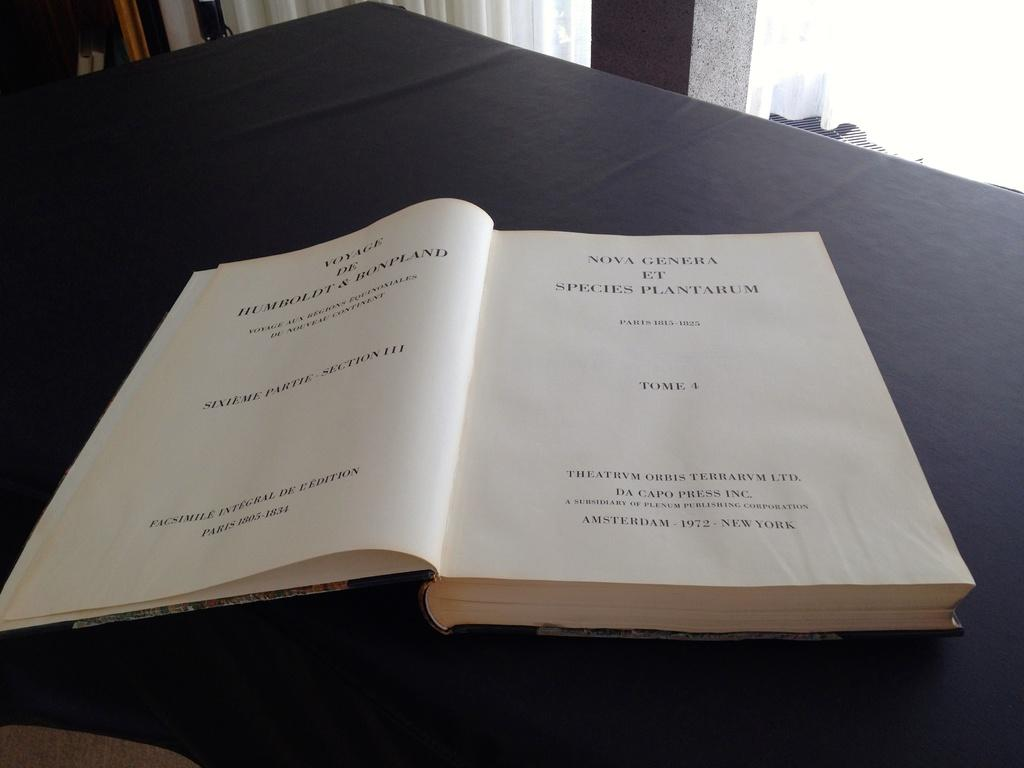<image>
Render a clear and concise summary of the photo. Tome 4 was written in Paris from 1815-1825. 